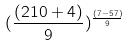Convert formula to latex. <formula><loc_0><loc_0><loc_500><loc_500>( \frac { ( 2 1 0 + 4 ) } { 9 } ) ^ { \frac { ( 7 - 5 7 ) } { 9 } }</formula> 